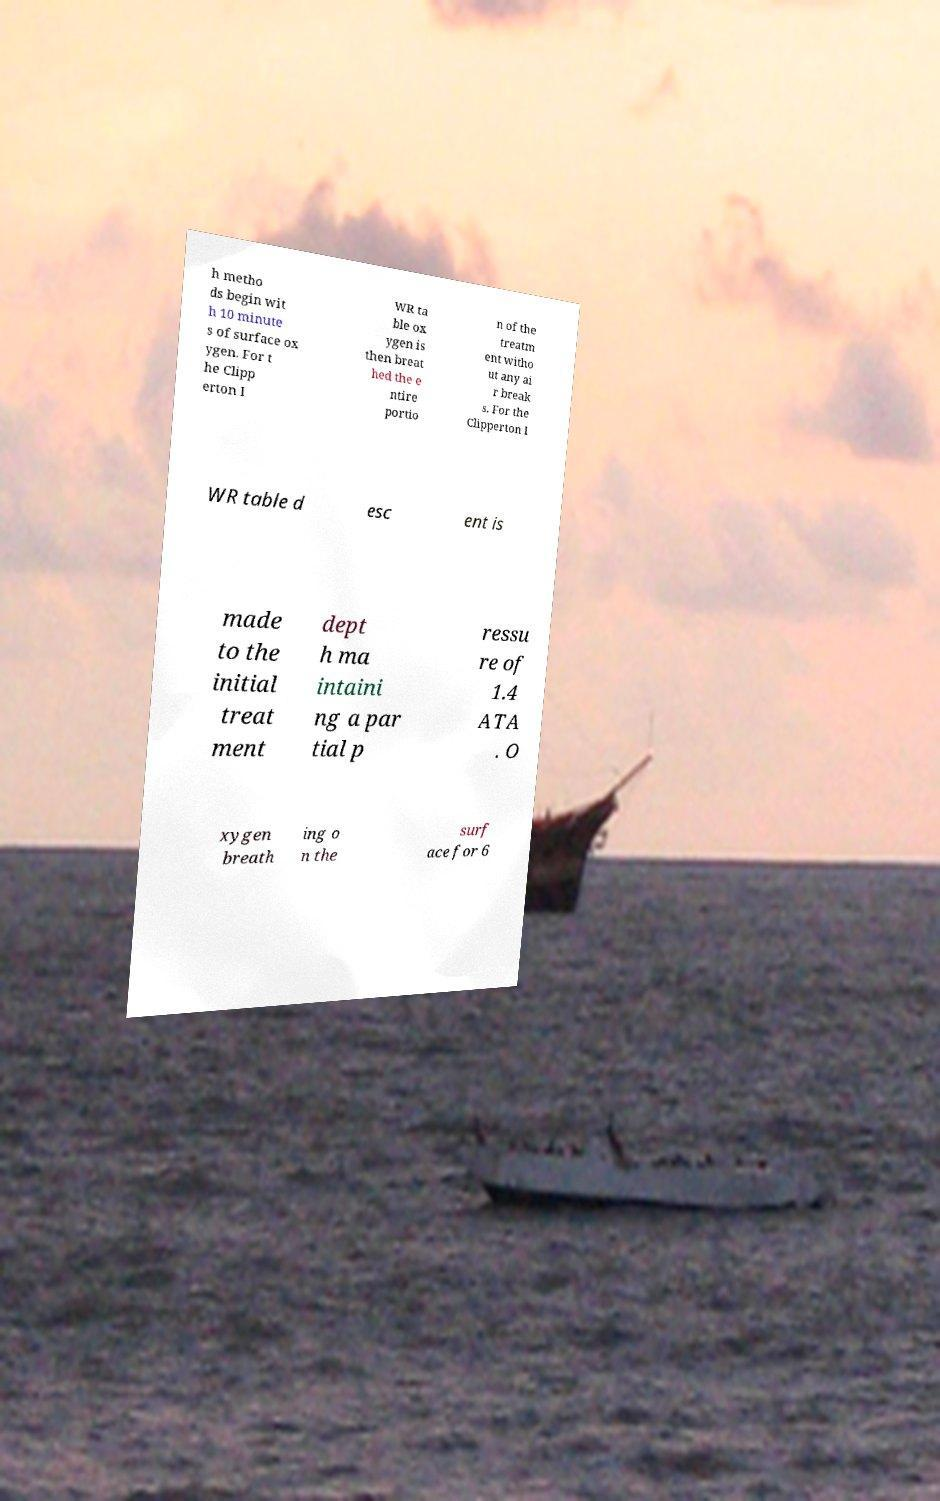Could you extract and type out the text from this image? h metho ds begin wit h 10 minute s of surface ox ygen. For t he Clipp erton I WR ta ble ox ygen is then breat hed the e ntire portio n of the treatm ent witho ut any ai r break s. For the Clipperton I WR table d esc ent is made to the initial treat ment dept h ma intaini ng a par tial p ressu re of 1.4 ATA . O xygen breath ing o n the surf ace for 6 